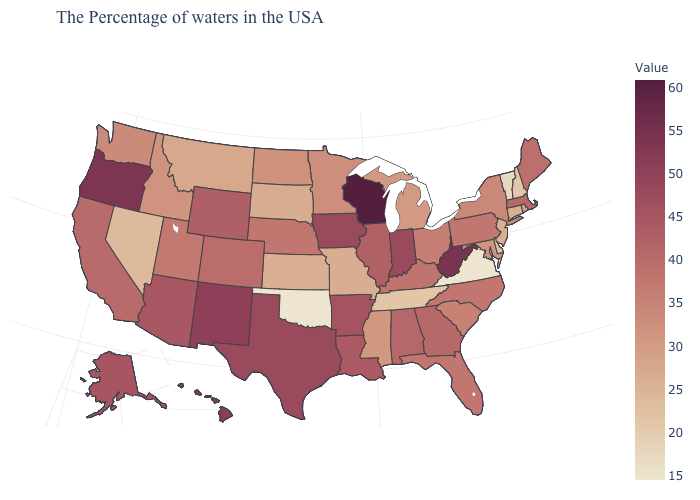Among the states that border Michigan , does Wisconsin have the highest value?
Be succinct. Yes. Is the legend a continuous bar?
Answer briefly. Yes. Which states have the lowest value in the USA?
Write a very short answer. Virginia, Oklahoma. Among the states that border Kansas , which have the lowest value?
Concise answer only. Oklahoma. Does Mississippi have the lowest value in the USA?
Keep it brief. No. Which states have the lowest value in the USA?
Concise answer only. Virginia, Oklahoma. Among the states that border Ohio , which have the highest value?
Answer briefly. West Virginia. Among the states that border North Dakota , which have the highest value?
Be succinct. Minnesota. 